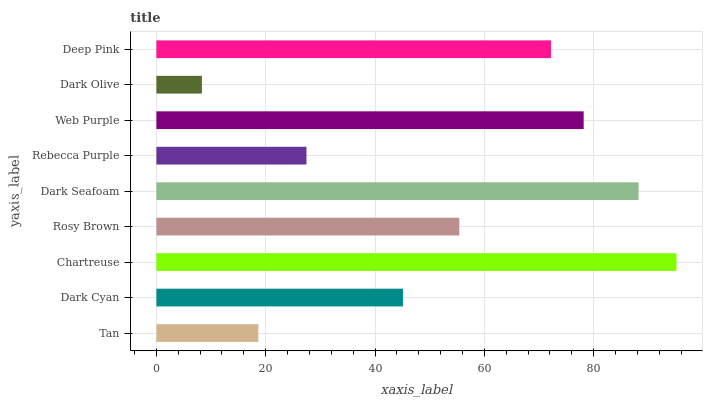Is Dark Olive the minimum?
Answer yes or no. Yes. Is Chartreuse the maximum?
Answer yes or no. Yes. Is Dark Cyan the minimum?
Answer yes or no. No. Is Dark Cyan the maximum?
Answer yes or no. No. Is Dark Cyan greater than Tan?
Answer yes or no. Yes. Is Tan less than Dark Cyan?
Answer yes or no. Yes. Is Tan greater than Dark Cyan?
Answer yes or no. No. Is Dark Cyan less than Tan?
Answer yes or no. No. Is Rosy Brown the high median?
Answer yes or no. Yes. Is Rosy Brown the low median?
Answer yes or no. Yes. Is Dark Olive the high median?
Answer yes or no. No. Is Chartreuse the low median?
Answer yes or no. No. 